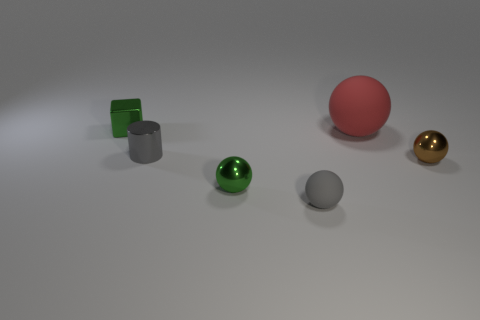Subtract all big red rubber balls. How many balls are left? 3 Subtract all green balls. How many balls are left? 3 Add 3 tiny cylinders. How many objects exist? 9 Subtract all purple balls. Subtract all red cylinders. How many balls are left? 4 Subtract all cylinders. How many objects are left? 5 Add 6 small purple matte spheres. How many small purple matte spheres exist? 6 Subtract 0 blue cylinders. How many objects are left? 6 Subtract all blue things. Subtract all large matte spheres. How many objects are left? 5 Add 3 small gray things. How many small gray things are left? 5 